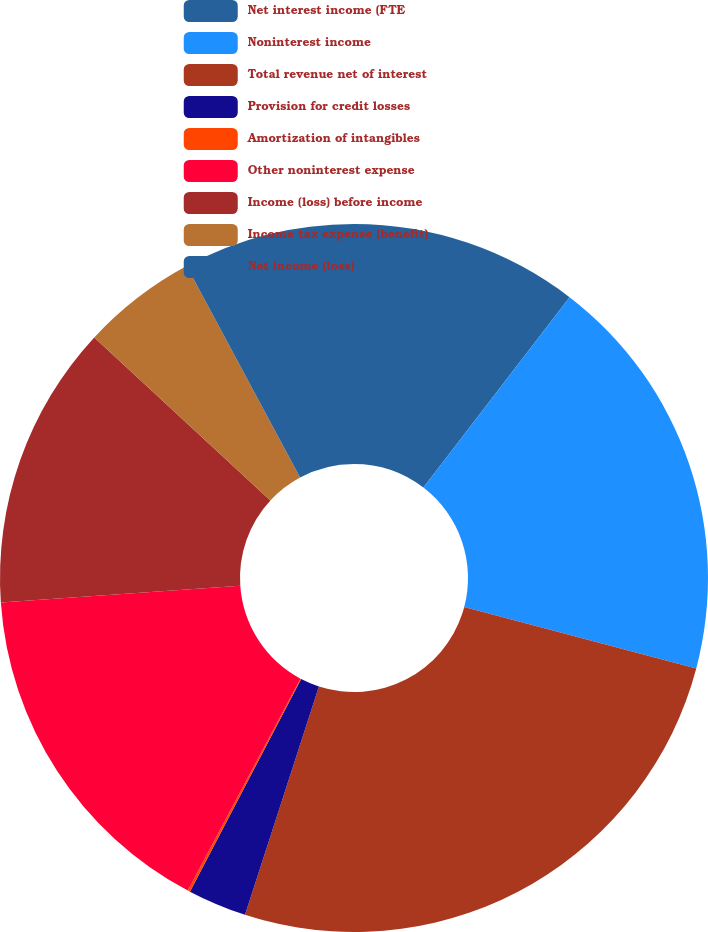<chart> <loc_0><loc_0><loc_500><loc_500><pie_chart><fcel>Net interest income (FTE<fcel>Noninterest income<fcel>Total revenue net of interest<fcel>Provision for credit losses<fcel>Amortization of intangibles<fcel>Other noninterest expense<fcel>Income (loss) before income<fcel>Income tax expense (benefit)<fcel>Net income (loss)<nl><fcel>10.42%<fcel>18.69%<fcel>25.87%<fcel>2.69%<fcel>0.11%<fcel>16.12%<fcel>12.99%<fcel>5.27%<fcel>7.84%<nl></chart> 